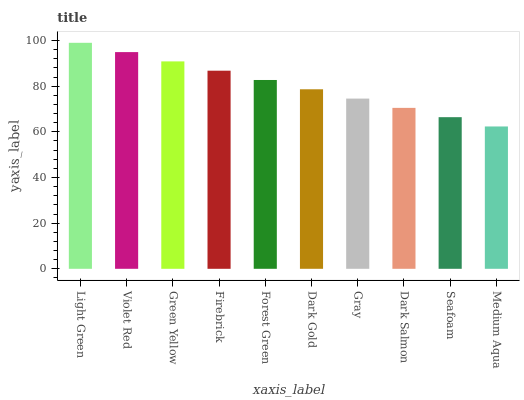Is Medium Aqua the minimum?
Answer yes or no. Yes. Is Light Green the maximum?
Answer yes or no. Yes. Is Violet Red the minimum?
Answer yes or no. No. Is Violet Red the maximum?
Answer yes or no. No. Is Light Green greater than Violet Red?
Answer yes or no. Yes. Is Violet Red less than Light Green?
Answer yes or no. Yes. Is Violet Red greater than Light Green?
Answer yes or no. No. Is Light Green less than Violet Red?
Answer yes or no. No. Is Forest Green the high median?
Answer yes or no. Yes. Is Dark Gold the low median?
Answer yes or no. Yes. Is Firebrick the high median?
Answer yes or no. No. Is Medium Aqua the low median?
Answer yes or no. No. 